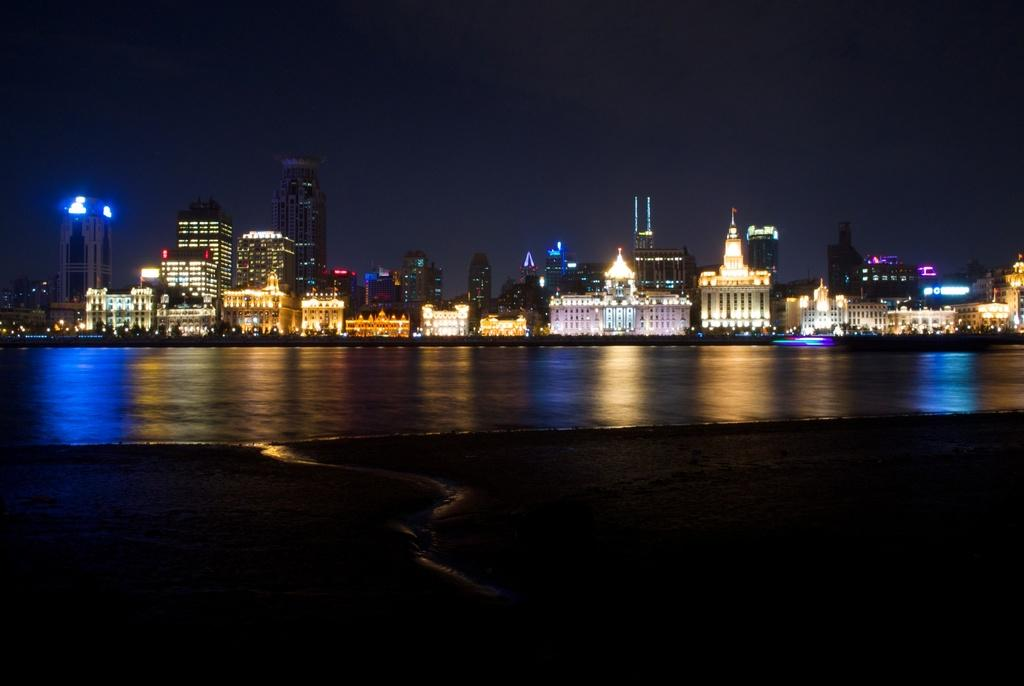What is visible in the image? Water, ground, buildings, lights, and the sky are visible in the image. Can you describe the setting of the image? The image shows a scene with water, ground, and buildings in the background, along with lights and the sky. What type of environment might this image depict? The image might depict a city or urban environment, given the presence of buildings and lights. How many cattle can be seen grazing on the paper in the image? There are no cattle or paper present in the image. 